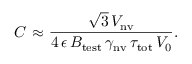Convert formula to latex. <formula><loc_0><loc_0><loc_500><loc_500>C { \approx } \frac { \sqrt { 3 } \, V _ { n v } } { 4 \, \epsilon \, B _ { t e s t } \, \gamma _ { n v } \, \tau _ { t o t } \, V _ { 0 } } .</formula> 